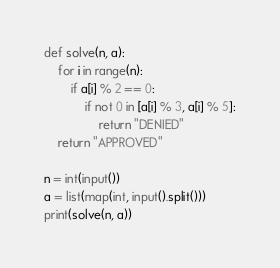Convert code to text. <code><loc_0><loc_0><loc_500><loc_500><_Python_>def solve(n, a):
    for i in range(n):
        if a[i] % 2 == 0:
            if not 0 in [a[i] % 3, a[i] % 5]:
                return "DENIED"
    return "APPROVED"

n = int(input())
a = list(map(int, input().split()))
print(solve(n, a))</code> 